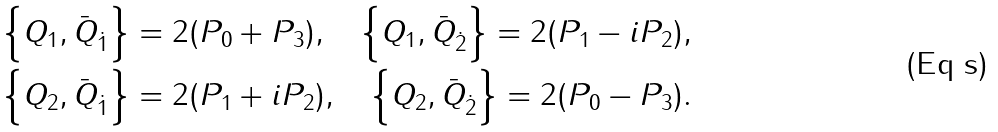<formula> <loc_0><loc_0><loc_500><loc_500>\left \{ Q _ { 1 } , \bar { Q } _ { \dot { 1 } } \right \} = 2 ( P _ { 0 } + P _ { 3 } ) , \quad \left \{ Q _ { 1 } , \bar { Q } _ { \dot { 2 } } \right \} = 2 ( P _ { 1 } - i P _ { 2 } ) , \\ \left \{ Q _ { 2 } , \bar { Q } _ { \dot { 1 } } \right \} = 2 ( P _ { 1 } + i P _ { 2 } ) , \quad \left \{ Q _ { 2 } , \bar { Q } _ { \dot { 2 } } \right \} = 2 ( P _ { 0 } - P _ { 3 } ) .</formula> 